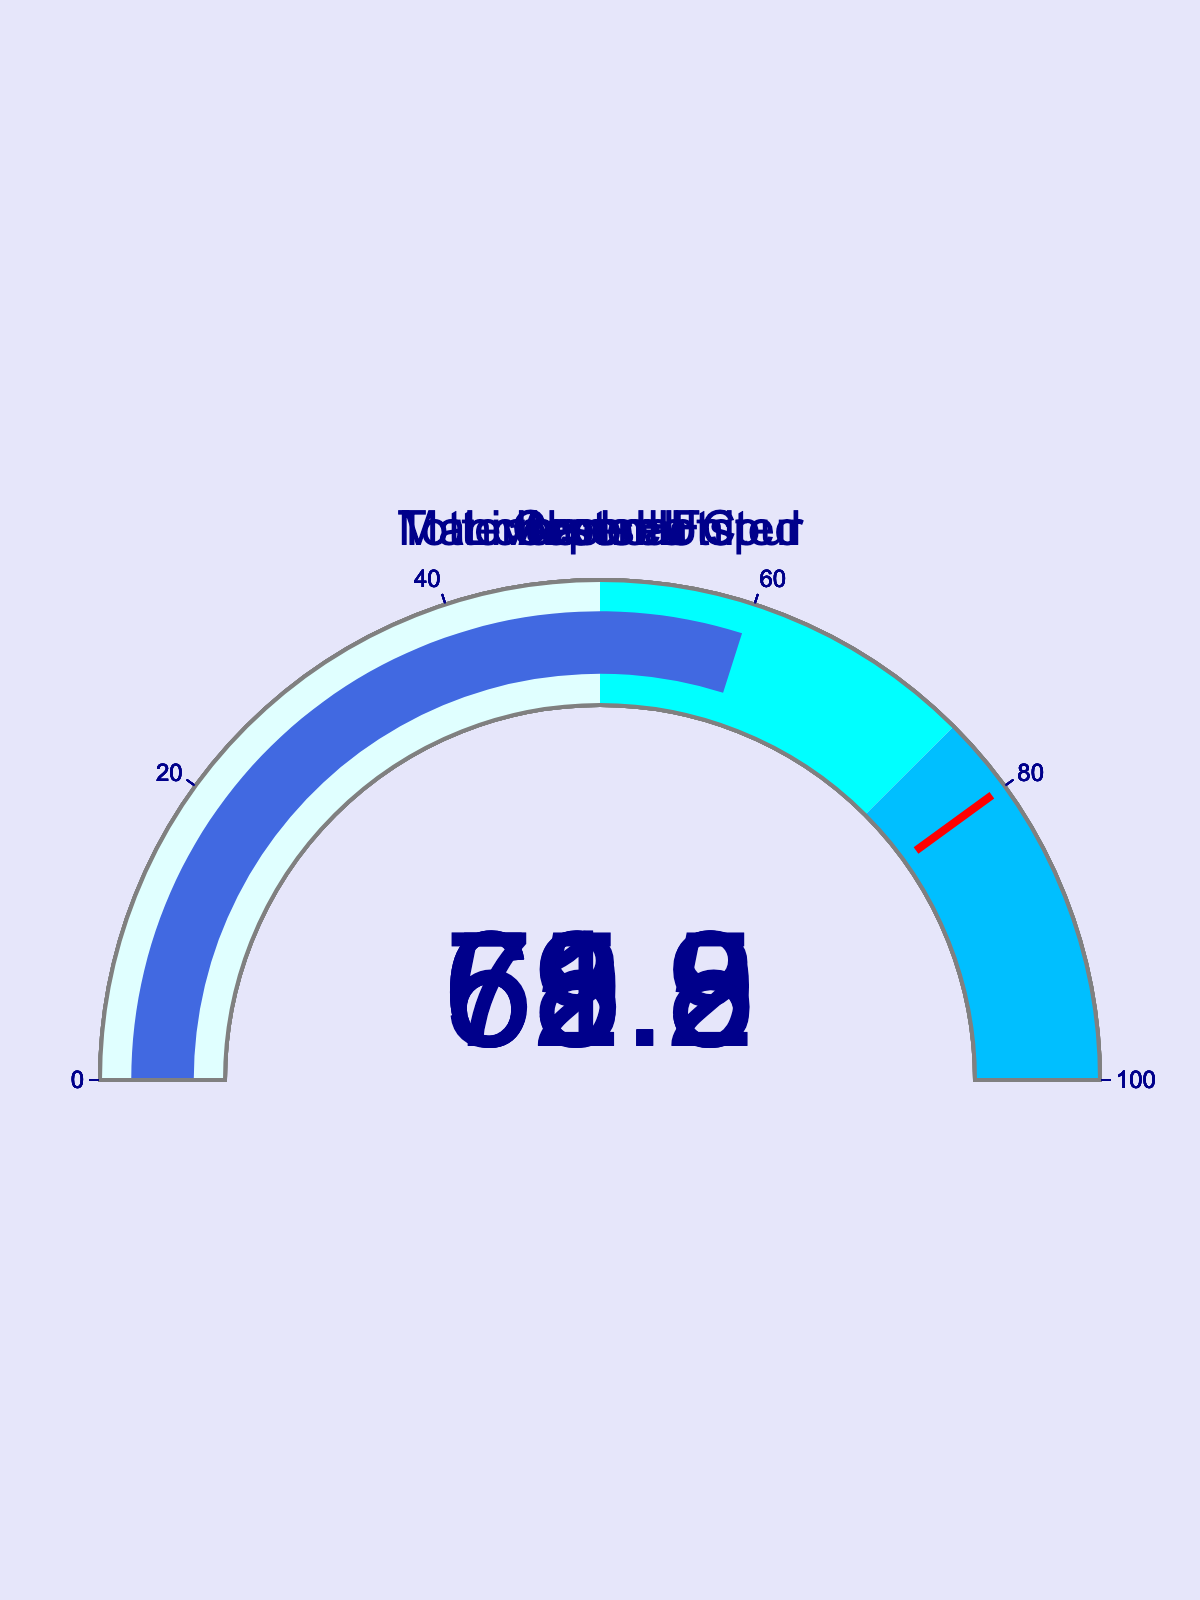What is Tottenham Hotspur's win percentage? Look at the gauge chart labeled "Tottenham Hotspur" and read the number displayed at the center of the gauge.
Answer: 59.8 Which team has the highest win percentage? Compare the numbers at the center of each gauge. The highest number is Liverpool FC with 72.5%.
Answer: Liverpool FC What is the average win percentage of all the teams? Sum the win percentages: 68.2 + 72.5 + 65.9 + 61.3 + 59.8 = 327.7. There are 5 teams, so the average is 327.7 / 5 = 65.54.
Answer: 65.54 What range does Manchester United's win percentage fall into? Refer to the color steps on the gauge: 0-50 (lightcyan), 50-75 (cyan), 75-100 (deepskyblue). Manchester United's win percentage of 68.2 falls into the 50-75 range (cyan).
Answer: 50-75 (cyan) By how much does Chelsea's win percentage differ from Arsenal's? Subtract Arsenal's win percentage from Chelsea's: 65.9 - 61.3 = 4.6.
Answer: 4.6 Which team has a win percentage closest to 70%? Compare each team's win percentage to 70%: Manchester United (68.2), Liverpool FC (72.5), Arsenal (65.9), Chelsea (61.3), Tottenham Hotspur (59.8). The closest is Manchester United at 68.2%.
Answer: Manchester United What is the median win percentage of all the teams? Arrange the percentages in ascending order: 59.8, 61.3, 65.9, 68.2, 72.5. The median value is the middle number, which is 65.9.
Answer: 65.9 How many teams have a win percentage above 60%? Count the teams with win percentages above 60%: Manchester United (68.2), Liverpool FC (72.5), Arsenal (65.9), Chelsea (61.3). There are 4 teams.
Answer: 4 